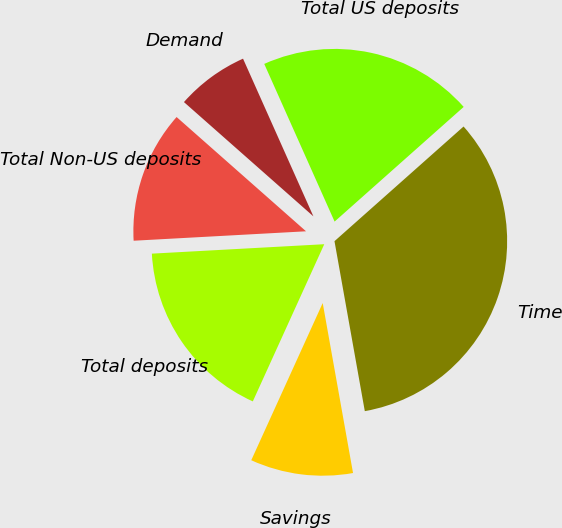Convert chart. <chart><loc_0><loc_0><loc_500><loc_500><pie_chart><fcel>Savings<fcel>Time<fcel>Total US deposits<fcel>Demand<fcel>Total Non-US deposits<fcel>Total deposits<nl><fcel>9.6%<fcel>33.75%<fcel>20.12%<fcel>6.81%<fcel>12.38%<fcel>17.34%<nl></chart> 